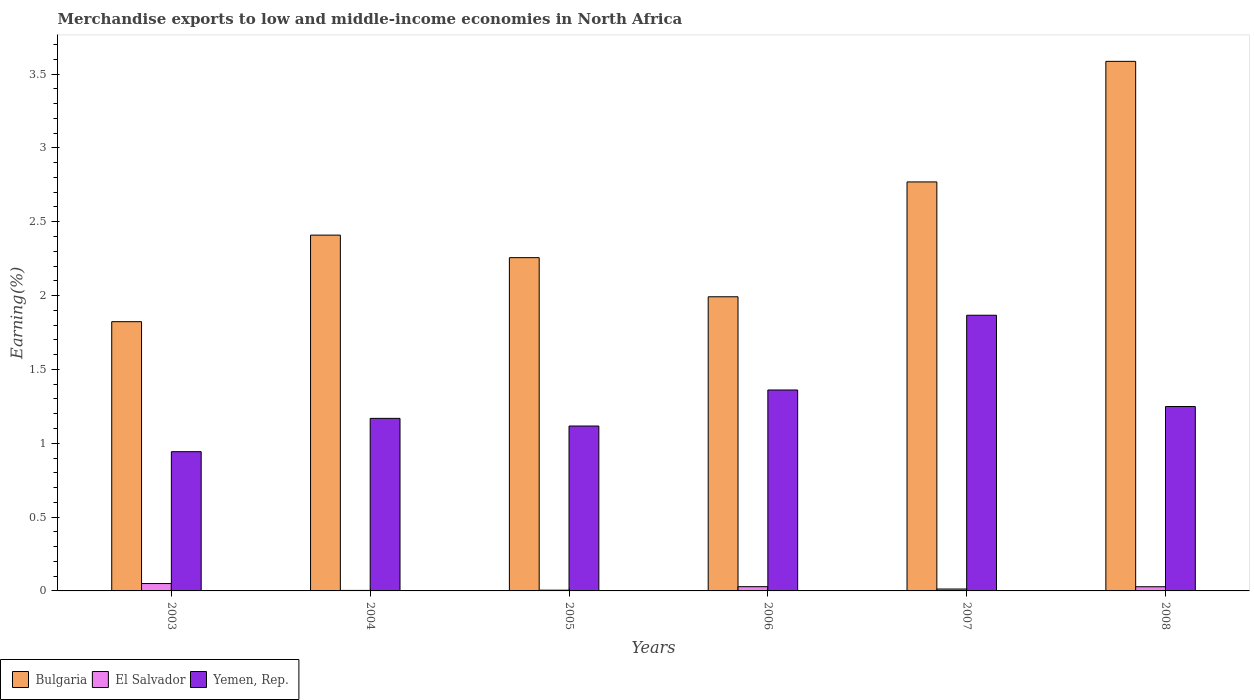How many groups of bars are there?
Make the answer very short. 6. Are the number of bars on each tick of the X-axis equal?
Keep it short and to the point. Yes. How many bars are there on the 6th tick from the left?
Ensure brevity in your answer.  3. How many bars are there on the 1st tick from the right?
Make the answer very short. 3. What is the percentage of amount earned from merchandise exports in El Salvador in 2006?
Keep it short and to the point. 0.03. Across all years, what is the maximum percentage of amount earned from merchandise exports in El Salvador?
Make the answer very short. 0.05. Across all years, what is the minimum percentage of amount earned from merchandise exports in El Salvador?
Your answer should be very brief. 0. What is the total percentage of amount earned from merchandise exports in El Salvador in the graph?
Provide a short and direct response. 0.13. What is the difference between the percentage of amount earned from merchandise exports in El Salvador in 2005 and that in 2008?
Provide a succinct answer. -0.02. What is the difference between the percentage of amount earned from merchandise exports in Yemen, Rep. in 2007 and the percentage of amount earned from merchandise exports in El Salvador in 2004?
Provide a succinct answer. 1.86. What is the average percentage of amount earned from merchandise exports in El Salvador per year?
Make the answer very short. 0.02. In the year 2005, what is the difference between the percentage of amount earned from merchandise exports in Yemen, Rep. and percentage of amount earned from merchandise exports in El Salvador?
Give a very brief answer. 1.11. In how many years, is the percentage of amount earned from merchandise exports in Bulgaria greater than 2.2 %?
Provide a succinct answer. 4. What is the ratio of the percentage of amount earned from merchandise exports in El Salvador in 2004 to that in 2007?
Provide a short and direct response. 0.27. Is the percentage of amount earned from merchandise exports in El Salvador in 2003 less than that in 2007?
Give a very brief answer. No. What is the difference between the highest and the second highest percentage of amount earned from merchandise exports in Yemen, Rep.?
Ensure brevity in your answer.  0.51. What is the difference between the highest and the lowest percentage of amount earned from merchandise exports in El Salvador?
Provide a short and direct response. 0.05. What does the 1st bar from the right in 2003 represents?
Provide a succinct answer. Yemen, Rep. How many bars are there?
Offer a terse response. 18. Are all the bars in the graph horizontal?
Provide a short and direct response. No. What is the difference between two consecutive major ticks on the Y-axis?
Provide a short and direct response. 0.5. Does the graph contain grids?
Provide a short and direct response. No. Where does the legend appear in the graph?
Provide a short and direct response. Bottom left. How many legend labels are there?
Provide a succinct answer. 3. What is the title of the graph?
Ensure brevity in your answer.  Merchandise exports to low and middle-income economies in North Africa. Does "Palau" appear as one of the legend labels in the graph?
Provide a succinct answer. No. What is the label or title of the X-axis?
Keep it short and to the point. Years. What is the label or title of the Y-axis?
Offer a terse response. Earning(%). What is the Earning(%) in Bulgaria in 2003?
Offer a terse response. 1.82. What is the Earning(%) of El Salvador in 2003?
Offer a terse response. 0.05. What is the Earning(%) of Yemen, Rep. in 2003?
Your answer should be compact. 0.94. What is the Earning(%) in Bulgaria in 2004?
Keep it short and to the point. 2.41. What is the Earning(%) in El Salvador in 2004?
Offer a very short reply. 0. What is the Earning(%) in Yemen, Rep. in 2004?
Your response must be concise. 1.17. What is the Earning(%) of Bulgaria in 2005?
Keep it short and to the point. 2.26. What is the Earning(%) of El Salvador in 2005?
Ensure brevity in your answer.  0.01. What is the Earning(%) in Yemen, Rep. in 2005?
Provide a short and direct response. 1.12. What is the Earning(%) of Bulgaria in 2006?
Offer a terse response. 1.99. What is the Earning(%) of El Salvador in 2006?
Give a very brief answer. 0.03. What is the Earning(%) in Yemen, Rep. in 2006?
Ensure brevity in your answer.  1.36. What is the Earning(%) of Bulgaria in 2007?
Provide a succinct answer. 2.77. What is the Earning(%) of El Salvador in 2007?
Provide a succinct answer. 0.01. What is the Earning(%) of Yemen, Rep. in 2007?
Give a very brief answer. 1.87. What is the Earning(%) of Bulgaria in 2008?
Offer a very short reply. 3.59. What is the Earning(%) in El Salvador in 2008?
Provide a short and direct response. 0.03. What is the Earning(%) of Yemen, Rep. in 2008?
Provide a short and direct response. 1.25. Across all years, what is the maximum Earning(%) in Bulgaria?
Make the answer very short. 3.59. Across all years, what is the maximum Earning(%) in El Salvador?
Provide a short and direct response. 0.05. Across all years, what is the maximum Earning(%) in Yemen, Rep.?
Provide a succinct answer. 1.87. Across all years, what is the minimum Earning(%) of Bulgaria?
Give a very brief answer. 1.82. Across all years, what is the minimum Earning(%) in El Salvador?
Provide a short and direct response. 0. Across all years, what is the minimum Earning(%) of Yemen, Rep.?
Give a very brief answer. 0.94. What is the total Earning(%) of Bulgaria in the graph?
Make the answer very short. 14.84. What is the total Earning(%) of El Salvador in the graph?
Ensure brevity in your answer.  0.13. What is the total Earning(%) in Yemen, Rep. in the graph?
Provide a short and direct response. 7.7. What is the difference between the Earning(%) of Bulgaria in 2003 and that in 2004?
Your answer should be compact. -0.59. What is the difference between the Earning(%) in El Salvador in 2003 and that in 2004?
Ensure brevity in your answer.  0.05. What is the difference between the Earning(%) in Yemen, Rep. in 2003 and that in 2004?
Your answer should be very brief. -0.23. What is the difference between the Earning(%) of Bulgaria in 2003 and that in 2005?
Give a very brief answer. -0.43. What is the difference between the Earning(%) of El Salvador in 2003 and that in 2005?
Provide a short and direct response. 0.04. What is the difference between the Earning(%) of Yemen, Rep. in 2003 and that in 2005?
Offer a very short reply. -0.17. What is the difference between the Earning(%) of Bulgaria in 2003 and that in 2006?
Make the answer very short. -0.17. What is the difference between the Earning(%) of El Salvador in 2003 and that in 2006?
Offer a very short reply. 0.02. What is the difference between the Earning(%) of Yemen, Rep. in 2003 and that in 2006?
Offer a very short reply. -0.42. What is the difference between the Earning(%) of Bulgaria in 2003 and that in 2007?
Your answer should be very brief. -0.95. What is the difference between the Earning(%) in El Salvador in 2003 and that in 2007?
Provide a succinct answer. 0.04. What is the difference between the Earning(%) in Yemen, Rep. in 2003 and that in 2007?
Provide a short and direct response. -0.92. What is the difference between the Earning(%) in Bulgaria in 2003 and that in 2008?
Give a very brief answer. -1.76. What is the difference between the Earning(%) in El Salvador in 2003 and that in 2008?
Make the answer very short. 0.02. What is the difference between the Earning(%) in Yemen, Rep. in 2003 and that in 2008?
Offer a very short reply. -0.31. What is the difference between the Earning(%) of Bulgaria in 2004 and that in 2005?
Keep it short and to the point. 0.15. What is the difference between the Earning(%) in El Salvador in 2004 and that in 2005?
Offer a terse response. -0. What is the difference between the Earning(%) of Yemen, Rep. in 2004 and that in 2005?
Ensure brevity in your answer.  0.05. What is the difference between the Earning(%) of Bulgaria in 2004 and that in 2006?
Your response must be concise. 0.42. What is the difference between the Earning(%) in El Salvador in 2004 and that in 2006?
Your response must be concise. -0.03. What is the difference between the Earning(%) in Yemen, Rep. in 2004 and that in 2006?
Your answer should be compact. -0.19. What is the difference between the Earning(%) in Bulgaria in 2004 and that in 2007?
Offer a very short reply. -0.36. What is the difference between the Earning(%) in El Salvador in 2004 and that in 2007?
Keep it short and to the point. -0.01. What is the difference between the Earning(%) of Yemen, Rep. in 2004 and that in 2007?
Make the answer very short. -0.7. What is the difference between the Earning(%) in Bulgaria in 2004 and that in 2008?
Your response must be concise. -1.18. What is the difference between the Earning(%) in El Salvador in 2004 and that in 2008?
Your answer should be compact. -0.02. What is the difference between the Earning(%) in Yemen, Rep. in 2004 and that in 2008?
Your answer should be very brief. -0.08. What is the difference between the Earning(%) of Bulgaria in 2005 and that in 2006?
Your answer should be very brief. 0.27. What is the difference between the Earning(%) in El Salvador in 2005 and that in 2006?
Make the answer very short. -0.02. What is the difference between the Earning(%) in Yemen, Rep. in 2005 and that in 2006?
Offer a very short reply. -0.24. What is the difference between the Earning(%) of Bulgaria in 2005 and that in 2007?
Make the answer very short. -0.51. What is the difference between the Earning(%) of El Salvador in 2005 and that in 2007?
Your answer should be very brief. -0.01. What is the difference between the Earning(%) of Yemen, Rep. in 2005 and that in 2007?
Your response must be concise. -0.75. What is the difference between the Earning(%) of Bulgaria in 2005 and that in 2008?
Provide a short and direct response. -1.33. What is the difference between the Earning(%) of El Salvador in 2005 and that in 2008?
Your response must be concise. -0.02. What is the difference between the Earning(%) of Yemen, Rep. in 2005 and that in 2008?
Your answer should be very brief. -0.13. What is the difference between the Earning(%) in Bulgaria in 2006 and that in 2007?
Your response must be concise. -0.78. What is the difference between the Earning(%) of El Salvador in 2006 and that in 2007?
Your answer should be very brief. 0.02. What is the difference between the Earning(%) of Yemen, Rep. in 2006 and that in 2007?
Your answer should be very brief. -0.51. What is the difference between the Earning(%) of Bulgaria in 2006 and that in 2008?
Ensure brevity in your answer.  -1.59. What is the difference between the Earning(%) of El Salvador in 2006 and that in 2008?
Keep it short and to the point. 0. What is the difference between the Earning(%) of Yemen, Rep. in 2006 and that in 2008?
Keep it short and to the point. 0.11. What is the difference between the Earning(%) in Bulgaria in 2007 and that in 2008?
Keep it short and to the point. -0.82. What is the difference between the Earning(%) in El Salvador in 2007 and that in 2008?
Give a very brief answer. -0.02. What is the difference between the Earning(%) in Yemen, Rep. in 2007 and that in 2008?
Your answer should be very brief. 0.62. What is the difference between the Earning(%) in Bulgaria in 2003 and the Earning(%) in El Salvador in 2004?
Your response must be concise. 1.82. What is the difference between the Earning(%) of Bulgaria in 2003 and the Earning(%) of Yemen, Rep. in 2004?
Your response must be concise. 0.65. What is the difference between the Earning(%) of El Salvador in 2003 and the Earning(%) of Yemen, Rep. in 2004?
Offer a terse response. -1.12. What is the difference between the Earning(%) of Bulgaria in 2003 and the Earning(%) of El Salvador in 2005?
Your response must be concise. 1.82. What is the difference between the Earning(%) in Bulgaria in 2003 and the Earning(%) in Yemen, Rep. in 2005?
Provide a succinct answer. 0.71. What is the difference between the Earning(%) in El Salvador in 2003 and the Earning(%) in Yemen, Rep. in 2005?
Give a very brief answer. -1.07. What is the difference between the Earning(%) of Bulgaria in 2003 and the Earning(%) of El Salvador in 2006?
Your answer should be compact. 1.79. What is the difference between the Earning(%) of Bulgaria in 2003 and the Earning(%) of Yemen, Rep. in 2006?
Your answer should be compact. 0.46. What is the difference between the Earning(%) of El Salvador in 2003 and the Earning(%) of Yemen, Rep. in 2006?
Your answer should be compact. -1.31. What is the difference between the Earning(%) in Bulgaria in 2003 and the Earning(%) in El Salvador in 2007?
Offer a very short reply. 1.81. What is the difference between the Earning(%) in Bulgaria in 2003 and the Earning(%) in Yemen, Rep. in 2007?
Your answer should be compact. -0.04. What is the difference between the Earning(%) in El Salvador in 2003 and the Earning(%) in Yemen, Rep. in 2007?
Keep it short and to the point. -1.82. What is the difference between the Earning(%) of Bulgaria in 2003 and the Earning(%) of El Salvador in 2008?
Offer a terse response. 1.79. What is the difference between the Earning(%) of Bulgaria in 2003 and the Earning(%) of Yemen, Rep. in 2008?
Your answer should be compact. 0.57. What is the difference between the Earning(%) of El Salvador in 2003 and the Earning(%) of Yemen, Rep. in 2008?
Your answer should be very brief. -1.2. What is the difference between the Earning(%) in Bulgaria in 2004 and the Earning(%) in El Salvador in 2005?
Offer a terse response. 2.4. What is the difference between the Earning(%) in Bulgaria in 2004 and the Earning(%) in Yemen, Rep. in 2005?
Offer a very short reply. 1.29. What is the difference between the Earning(%) of El Salvador in 2004 and the Earning(%) of Yemen, Rep. in 2005?
Your response must be concise. -1.11. What is the difference between the Earning(%) in Bulgaria in 2004 and the Earning(%) in El Salvador in 2006?
Keep it short and to the point. 2.38. What is the difference between the Earning(%) of Bulgaria in 2004 and the Earning(%) of Yemen, Rep. in 2006?
Give a very brief answer. 1.05. What is the difference between the Earning(%) in El Salvador in 2004 and the Earning(%) in Yemen, Rep. in 2006?
Offer a terse response. -1.36. What is the difference between the Earning(%) of Bulgaria in 2004 and the Earning(%) of El Salvador in 2007?
Your response must be concise. 2.4. What is the difference between the Earning(%) of Bulgaria in 2004 and the Earning(%) of Yemen, Rep. in 2007?
Make the answer very short. 0.54. What is the difference between the Earning(%) in El Salvador in 2004 and the Earning(%) in Yemen, Rep. in 2007?
Your answer should be compact. -1.86. What is the difference between the Earning(%) of Bulgaria in 2004 and the Earning(%) of El Salvador in 2008?
Make the answer very short. 2.38. What is the difference between the Earning(%) of Bulgaria in 2004 and the Earning(%) of Yemen, Rep. in 2008?
Ensure brevity in your answer.  1.16. What is the difference between the Earning(%) of El Salvador in 2004 and the Earning(%) of Yemen, Rep. in 2008?
Your answer should be compact. -1.25. What is the difference between the Earning(%) in Bulgaria in 2005 and the Earning(%) in El Salvador in 2006?
Offer a terse response. 2.23. What is the difference between the Earning(%) of Bulgaria in 2005 and the Earning(%) of Yemen, Rep. in 2006?
Your answer should be very brief. 0.9. What is the difference between the Earning(%) of El Salvador in 2005 and the Earning(%) of Yemen, Rep. in 2006?
Your answer should be very brief. -1.36. What is the difference between the Earning(%) in Bulgaria in 2005 and the Earning(%) in El Salvador in 2007?
Make the answer very short. 2.24. What is the difference between the Earning(%) of Bulgaria in 2005 and the Earning(%) of Yemen, Rep. in 2007?
Give a very brief answer. 0.39. What is the difference between the Earning(%) in El Salvador in 2005 and the Earning(%) in Yemen, Rep. in 2007?
Offer a very short reply. -1.86. What is the difference between the Earning(%) in Bulgaria in 2005 and the Earning(%) in El Salvador in 2008?
Provide a short and direct response. 2.23. What is the difference between the Earning(%) of Bulgaria in 2005 and the Earning(%) of Yemen, Rep. in 2008?
Provide a succinct answer. 1.01. What is the difference between the Earning(%) of El Salvador in 2005 and the Earning(%) of Yemen, Rep. in 2008?
Provide a short and direct response. -1.24. What is the difference between the Earning(%) of Bulgaria in 2006 and the Earning(%) of El Salvador in 2007?
Keep it short and to the point. 1.98. What is the difference between the Earning(%) in El Salvador in 2006 and the Earning(%) in Yemen, Rep. in 2007?
Provide a short and direct response. -1.84. What is the difference between the Earning(%) of Bulgaria in 2006 and the Earning(%) of El Salvador in 2008?
Make the answer very short. 1.96. What is the difference between the Earning(%) in Bulgaria in 2006 and the Earning(%) in Yemen, Rep. in 2008?
Provide a succinct answer. 0.74. What is the difference between the Earning(%) in El Salvador in 2006 and the Earning(%) in Yemen, Rep. in 2008?
Give a very brief answer. -1.22. What is the difference between the Earning(%) of Bulgaria in 2007 and the Earning(%) of El Salvador in 2008?
Offer a terse response. 2.74. What is the difference between the Earning(%) in Bulgaria in 2007 and the Earning(%) in Yemen, Rep. in 2008?
Offer a terse response. 1.52. What is the difference between the Earning(%) of El Salvador in 2007 and the Earning(%) of Yemen, Rep. in 2008?
Offer a very short reply. -1.24. What is the average Earning(%) in Bulgaria per year?
Your answer should be compact. 2.47. What is the average Earning(%) in El Salvador per year?
Provide a short and direct response. 0.02. What is the average Earning(%) of Yemen, Rep. per year?
Give a very brief answer. 1.28. In the year 2003, what is the difference between the Earning(%) in Bulgaria and Earning(%) in El Salvador?
Offer a very short reply. 1.77. In the year 2003, what is the difference between the Earning(%) in Bulgaria and Earning(%) in Yemen, Rep.?
Provide a short and direct response. 0.88. In the year 2003, what is the difference between the Earning(%) in El Salvador and Earning(%) in Yemen, Rep.?
Make the answer very short. -0.89. In the year 2004, what is the difference between the Earning(%) in Bulgaria and Earning(%) in El Salvador?
Provide a short and direct response. 2.41. In the year 2004, what is the difference between the Earning(%) of Bulgaria and Earning(%) of Yemen, Rep.?
Ensure brevity in your answer.  1.24. In the year 2004, what is the difference between the Earning(%) of El Salvador and Earning(%) of Yemen, Rep.?
Give a very brief answer. -1.17. In the year 2005, what is the difference between the Earning(%) in Bulgaria and Earning(%) in El Salvador?
Your response must be concise. 2.25. In the year 2005, what is the difference between the Earning(%) of Bulgaria and Earning(%) of Yemen, Rep.?
Your answer should be compact. 1.14. In the year 2005, what is the difference between the Earning(%) of El Salvador and Earning(%) of Yemen, Rep.?
Offer a very short reply. -1.11. In the year 2006, what is the difference between the Earning(%) of Bulgaria and Earning(%) of El Salvador?
Ensure brevity in your answer.  1.96. In the year 2006, what is the difference between the Earning(%) of Bulgaria and Earning(%) of Yemen, Rep.?
Your answer should be compact. 0.63. In the year 2006, what is the difference between the Earning(%) in El Salvador and Earning(%) in Yemen, Rep.?
Offer a terse response. -1.33. In the year 2007, what is the difference between the Earning(%) in Bulgaria and Earning(%) in El Salvador?
Offer a very short reply. 2.76. In the year 2007, what is the difference between the Earning(%) in Bulgaria and Earning(%) in Yemen, Rep.?
Offer a very short reply. 0.9. In the year 2007, what is the difference between the Earning(%) of El Salvador and Earning(%) of Yemen, Rep.?
Your response must be concise. -1.85. In the year 2008, what is the difference between the Earning(%) of Bulgaria and Earning(%) of El Salvador?
Provide a succinct answer. 3.56. In the year 2008, what is the difference between the Earning(%) of Bulgaria and Earning(%) of Yemen, Rep.?
Offer a very short reply. 2.34. In the year 2008, what is the difference between the Earning(%) of El Salvador and Earning(%) of Yemen, Rep.?
Your answer should be very brief. -1.22. What is the ratio of the Earning(%) of Bulgaria in 2003 to that in 2004?
Offer a terse response. 0.76. What is the ratio of the Earning(%) of El Salvador in 2003 to that in 2004?
Ensure brevity in your answer.  14.41. What is the ratio of the Earning(%) of Yemen, Rep. in 2003 to that in 2004?
Make the answer very short. 0.81. What is the ratio of the Earning(%) of Bulgaria in 2003 to that in 2005?
Your response must be concise. 0.81. What is the ratio of the Earning(%) of El Salvador in 2003 to that in 2005?
Your answer should be very brief. 9.99. What is the ratio of the Earning(%) in Yemen, Rep. in 2003 to that in 2005?
Offer a very short reply. 0.84. What is the ratio of the Earning(%) of Bulgaria in 2003 to that in 2006?
Provide a succinct answer. 0.92. What is the ratio of the Earning(%) in El Salvador in 2003 to that in 2006?
Give a very brief answer. 1.74. What is the ratio of the Earning(%) in Yemen, Rep. in 2003 to that in 2006?
Ensure brevity in your answer.  0.69. What is the ratio of the Earning(%) in Bulgaria in 2003 to that in 2007?
Offer a very short reply. 0.66. What is the ratio of the Earning(%) of El Salvador in 2003 to that in 2007?
Offer a very short reply. 3.88. What is the ratio of the Earning(%) in Yemen, Rep. in 2003 to that in 2007?
Give a very brief answer. 0.51. What is the ratio of the Earning(%) of Bulgaria in 2003 to that in 2008?
Your response must be concise. 0.51. What is the ratio of the Earning(%) of El Salvador in 2003 to that in 2008?
Ensure brevity in your answer.  1.77. What is the ratio of the Earning(%) in Yemen, Rep. in 2003 to that in 2008?
Your response must be concise. 0.76. What is the ratio of the Earning(%) of Bulgaria in 2004 to that in 2005?
Your answer should be compact. 1.07. What is the ratio of the Earning(%) in El Salvador in 2004 to that in 2005?
Offer a very short reply. 0.69. What is the ratio of the Earning(%) in Yemen, Rep. in 2004 to that in 2005?
Provide a succinct answer. 1.05. What is the ratio of the Earning(%) of Bulgaria in 2004 to that in 2006?
Your answer should be compact. 1.21. What is the ratio of the Earning(%) of El Salvador in 2004 to that in 2006?
Provide a succinct answer. 0.12. What is the ratio of the Earning(%) of Yemen, Rep. in 2004 to that in 2006?
Offer a terse response. 0.86. What is the ratio of the Earning(%) of Bulgaria in 2004 to that in 2007?
Your answer should be very brief. 0.87. What is the ratio of the Earning(%) of El Salvador in 2004 to that in 2007?
Provide a short and direct response. 0.27. What is the ratio of the Earning(%) in Yemen, Rep. in 2004 to that in 2007?
Provide a succinct answer. 0.63. What is the ratio of the Earning(%) of Bulgaria in 2004 to that in 2008?
Your answer should be very brief. 0.67. What is the ratio of the Earning(%) in El Salvador in 2004 to that in 2008?
Offer a very short reply. 0.12. What is the ratio of the Earning(%) in Yemen, Rep. in 2004 to that in 2008?
Keep it short and to the point. 0.94. What is the ratio of the Earning(%) of Bulgaria in 2005 to that in 2006?
Keep it short and to the point. 1.13. What is the ratio of the Earning(%) in El Salvador in 2005 to that in 2006?
Ensure brevity in your answer.  0.17. What is the ratio of the Earning(%) of Yemen, Rep. in 2005 to that in 2006?
Offer a terse response. 0.82. What is the ratio of the Earning(%) in Bulgaria in 2005 to that in 2007?
Ensure brevity in your answer.  0.81. What is the ratio of the Earning(%) of El Salvador in 2005 to that in 2007?
Offer a terse response. 0.39. What is the ratio of the Earning(%) in Yemen, Rep. in 2005 to that in 2007?
Offer a terse response. 0.6. What is the ratio of the Earning(%) in Bulgaria in 2005 to that in 2008?
Ensure brevity in your answer.  0.63. What is the ratio of the Earning(%) of El Salvador in 2005 to that in 2008?
Offer a very short reply. 0.18. What is the ratio of the Earning(%) of Yemen, Rep. in 2005 to that in 2008?
Give a very brief answer. 0.89. What is the ratio of the Earning(%) of Bulgaria in 2006 to that in 2007?
Keep it short and to the point. 0.72. What is the ratio of the Earning(%) in El Salvador in 2006 to that in 2007?
Make the answer very short. 2.23. What is the ratio of the Earning(%) of Yemen, Rep. in 2006 to that in 2007?
Keep it short and to the point. 0.73. What is the ratio of the Earning(%) in Bulgaria in 2006 to that in 2008?
Ensure brevity in your answer.  0.56. What is the ratio of the Earning(%) of El Salvador in 2006 to that in 2008?
Give a very brief answer. 1.01. What is the ratio of the Earning(%) of Yemen, Rep. in 2006 to that in 2008?
Provide a short and direct response. 1.09. What is the ratio of the Earning(%) of Bulgaria in 2007 to that in 2008?
Your response must be concise. 0.77. What is the ratio of the Earning(%) of El Salvador in 2007 to that in 2008?
Your response must be concise. 0.45. What is the ratio of the Earning(%) of Yemen, Rep. in 2007 to that in 2008?
Your response must be concise. 1.5. What is the difference between the highest and the second highest Earning(%) in Bulgaria?
Make the answer very short. 0.82. What is the difference between the highest and the second highest Earning(%) of El Salvador?
Keep it short and to the point. 0.02. What is the difference between the highest and the second highest Earning(%) of Yemen, Rep.?
Offer a terse response. 0.51. What is the difference between the highest and the lowest Earning(%) of Bulgaria?
Keep it short and to the point. 1.76. What is the difference between the highest and the lowest Earning(%) in El Salvador?
Your answer should be very brief. 0.05. What is the difference between the highest and the lowest Earning(%) of Yemen, Rep.?
Provide a short and direct response. 0.92. 